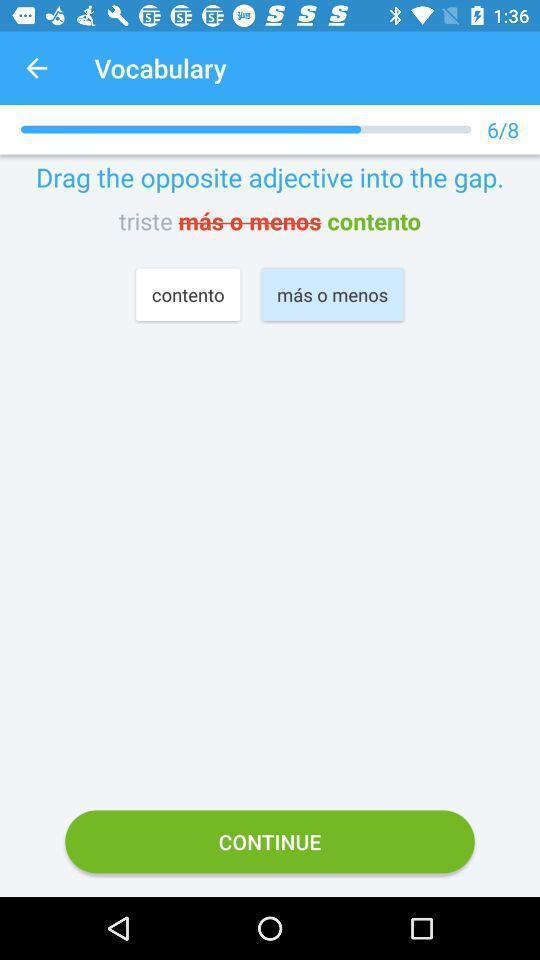Tell me about the visual elements in this screen capture. Vocabulary page. 